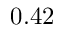Convert formula to latex. <formula><loc_0><loc_0><loc_500><loc_500>0 . 4 2</formula> 